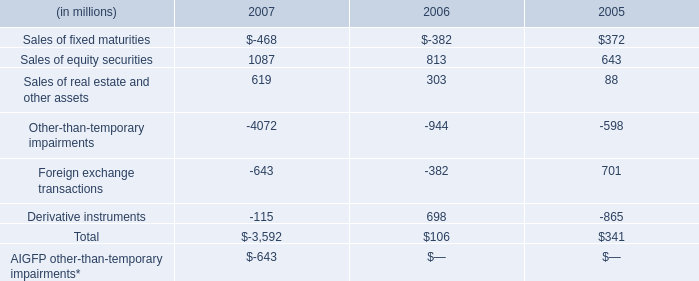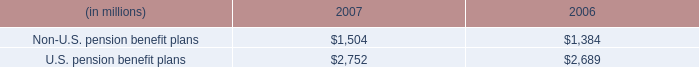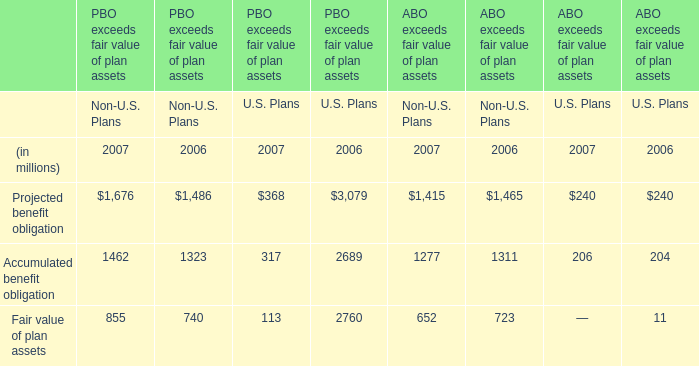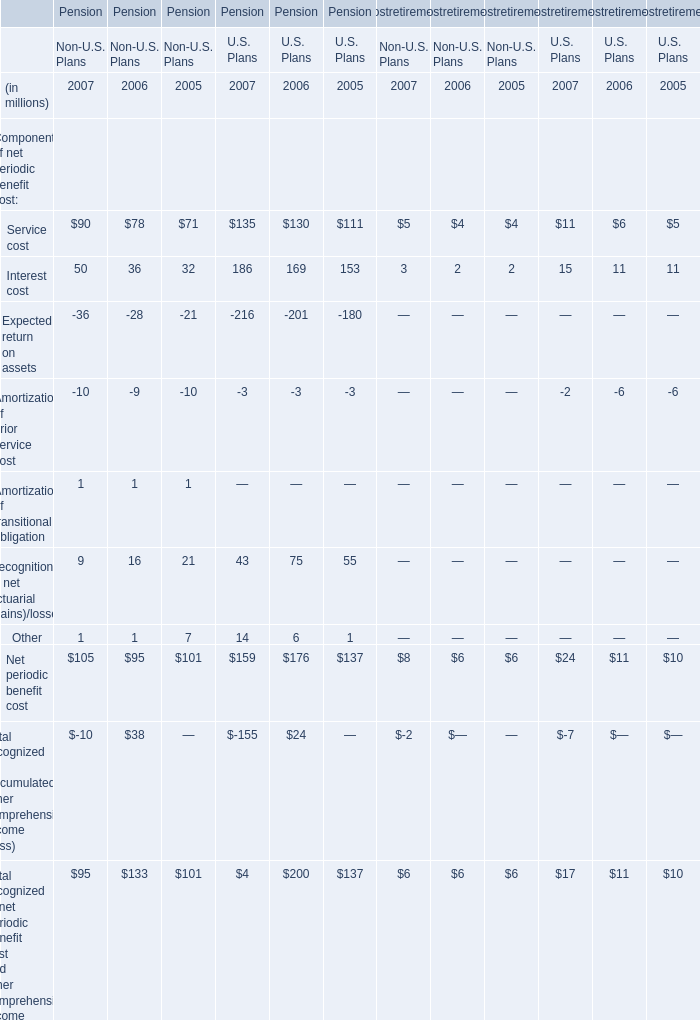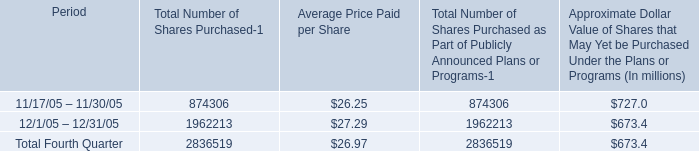If service cost develops with the same growth rate in 2007, what will it reach in 2008? (in million) 
Computations: ((((90 + 135) + 5) + 11) * (1 + ((((((((90 + 135) + 5) + 11) - 78) - 130) - 4) - 6) / (((78 + 130) + 4) + 6))))
Answer: 266.42661. 